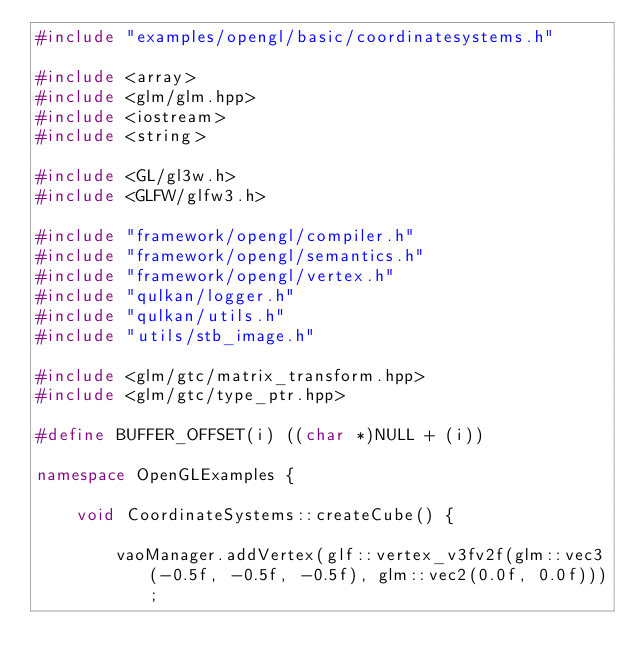Convert code to text. <code><loc_0><loc_0><loc_500><loc_500><_C++_>#include "examples/opengl/basic/coordinatesystems.h"

#include <array>
#include <glm/glm.hpp>
#include <iostream>
#include <string>

#include <GL/gl3w.h>
#include <GLFW/glfw3.h>

#include "framework/opengl/compiler.h"
#include "framework/opengl/semantics.h"
#include "framework/opengl/vertex.h"
#include "qulkan/logger.h"
#include "qulkan/utils.h"
#include "utils/stb_image.h"

#include <glm/gtc/matrix_transform.hpp>
#include <glm/gtc/type_ptr.hpp>

#define BUFFER_OFFSET(i) ((char *)NULL + (i))

namespace OpenGLExamples {

    void CoordinateSystems::createCube() {

        vaoManager.addVertex(glf::vertex_v3fv2f(glm::vec3(-0.5f, -0.5f, -0.5f), glm::vec2(0.0f, 0.0f)));</code> 